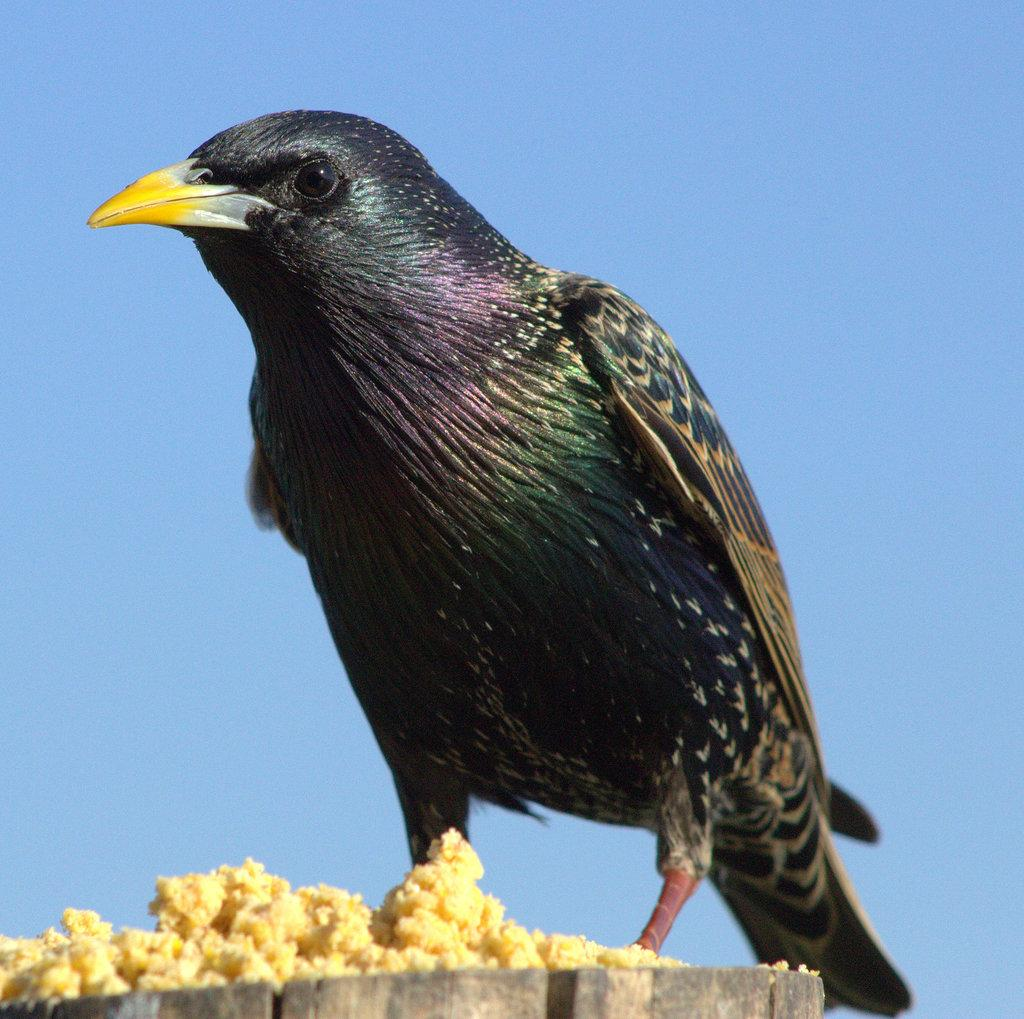What is on the wooden surface in the image? There is a bird on a wooden surface in the image. What is in front of the bird? There is food in front of the bird. What can be seen in the background of the image? The sky is visible in the background of the image, and it is blue. What grade of steel is used to make the bird's beak in the image? The bird in the image is a living creature and does not have a beak made of steel. 